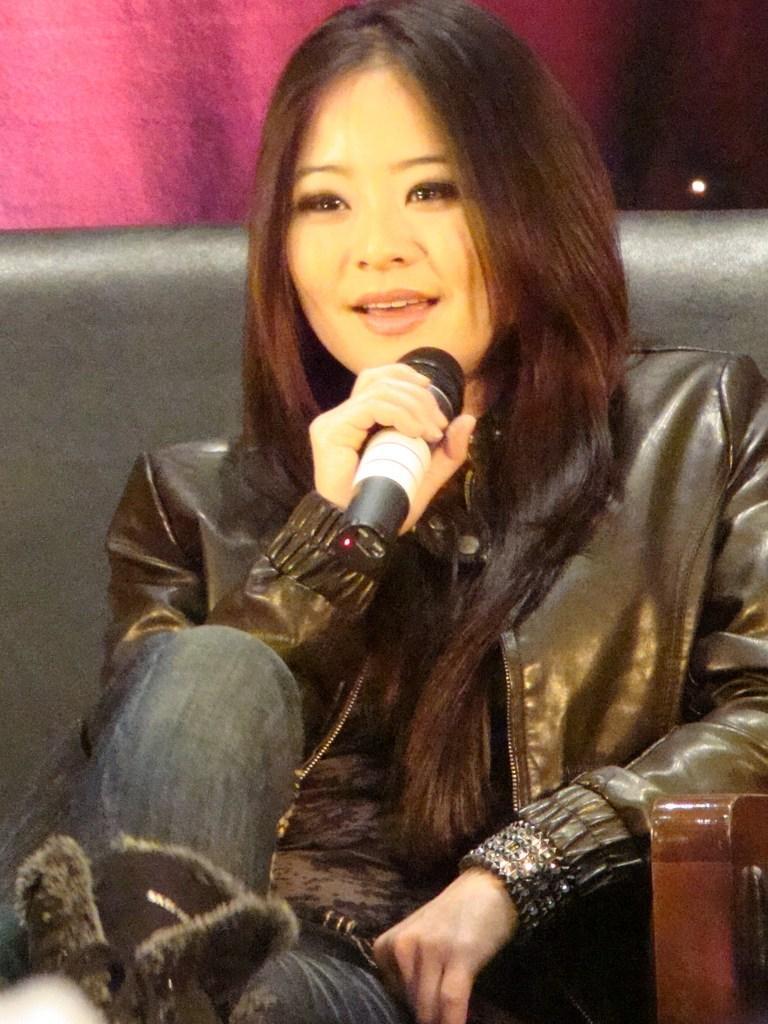Describe this image in one or two sentences. In a picture one woman is sitting on the sofa wearing a black jacket and jeans and holding a microphone. 